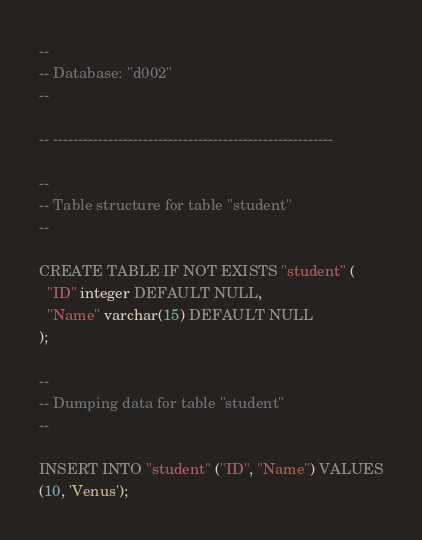<code> <loc_0><loc_0><loc_500><loc_500><_SQL_>--
-- Database: "d002"
--

-- --------------------------------------------------------

--
-- Table structure for table "student"
--

CREATE TABLE IF NOT EXISTS "student" (
  "ID" integer DEFAULT NULL,
  "Name" varchar(15) DEFAULT NULL
);

--
-- Dumping data for table "student"
--

INSERT INTO "student" ("ID", "Name") VALUES
(10, 'Venus');
</code> 